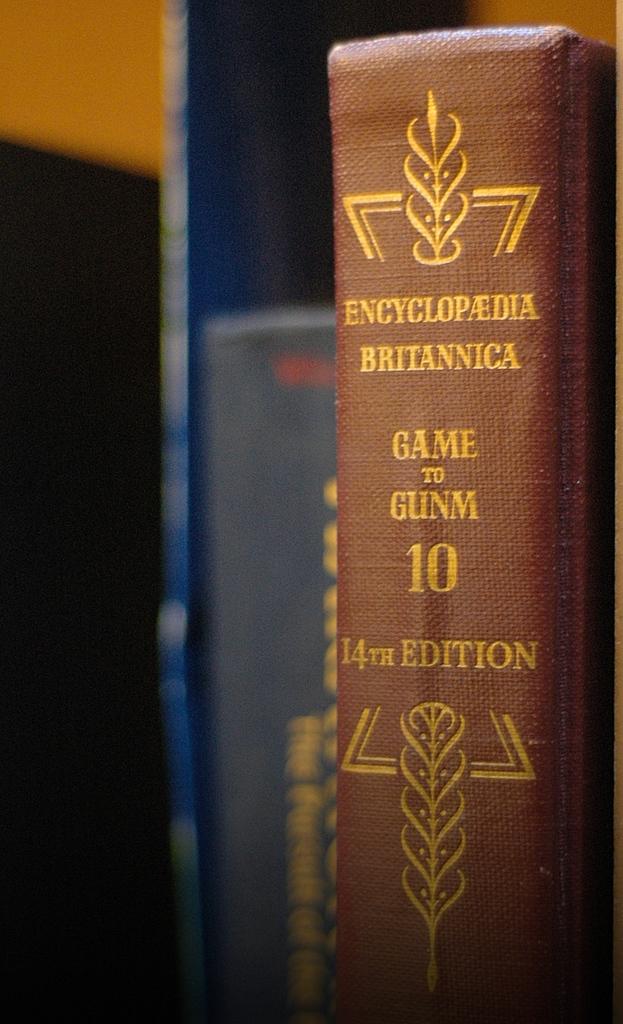What are the first and last entries in this encyclopedia?
Your response must be concise. Game gunm. 